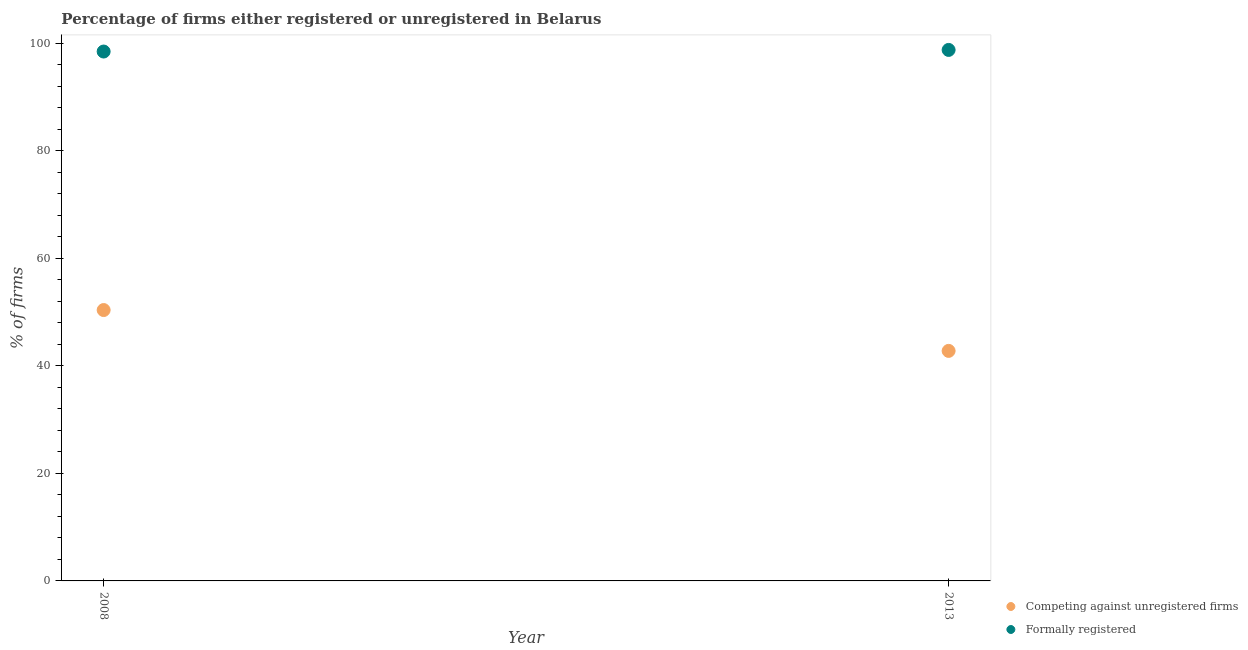Is the number of dotlines equal to the number of legend labels?
Offer a very short reply. Yes. What is the percentage of registered firms in 2008?
Your answer should be compact. 50.4. Across all years, what is the maximum percentage of formally registered firms?
Your answer should be compact. 98.8. Across all years, what is the minimum percentage of registered firms?
Keep it short and to the point. 42.8. In which year was the percentage of formally registered firms minimum?
Make the answer very short. 2008. What is the total percentage of registered firms in the graph?
Your answer should be compact. 93.2. What is the difference between the percentage of formally registered firms in 2008 and that in 2013?
Make the answer very short. -0.3. What is the difference between the percentage of registered firms in 2013 and the percentage of formally registered firms in 2008?
Ensure brevity in your answer.  -55.7. What is the average percentage of formally registered firms per year?
Offer a very short reply. 98.65. In the year 2008, what is the difference between the percentage of formally registered firms and percentage of registered firms?
Keep it short and to the point. 48.1. What is the ratio of the percentage of formally registered firms in 2008 to that in 2013?
Offer a terse response. 1. In how many years, is the percentage of formally registered firms greater than the average percentage of formally registered firms taken over all years?
Provide a short and direct response. 1. Does the percentage of formally registered firms monotonically increase over the years?
Offer a very short reply. Yes. Is the percentage of formally registered firms strictly greater than the percentage of registered firms over the years?
Provide a succinct answer. Yes. What is the difference between two consecutive major ticks on the Y-axis?
Ensure brevity in your answer.  20. How many legend labels are there?
Provide a succinct answer. 2. What is the title of the graph?
Ensure brevity in your answer.  Percentage of firms either registered or unregistered in Belarus. What is the label or title of the Y-axis?
Make the answer very short. % of firms. What is the % of firms in Competing against unregistered firms in 2008?
Offer a very short reply. 50.4. What is the % of firms in Formally registered in 2008?
Your answer should be very brief. 98.5. What is the % of firms in Competing against unregistered firms in 2013?
Your answer should be very brief. 42.8. What is the % of firms of Formally registered in 2013?
Keep it short and to the point. 98.8. Across all years, what is the maximum % of firms in Competing against unregistered firms?
Make the answer very short. 50.4. Across all years, what is the maximum % of firms in Formally registered?
Provide a succinct answer. 98.8. Across all years, what is the minimum % of firms in Competing against unregistered firms?
Offer a very short reply. 42.8. Across all years, what is the minimum % of firms of Formally registered?
Offer a very short reply. 98.5. What is the total % of firms of Competing against unregistered firms in the graph?
Keep it short and to the point. 93.2. What is the total % of firms in Formally registered in the graph?
Make the answer very short. 197.3. What is the difference between the % of firms of Formally registered in 2008 and that in 2013?
Ensure brevity in your answer.  -0.3. What is the difference between the % of firms of Competing against unregistered firms in 2008 and the % of firms of Formally registered in 2013?
Provide a succinct answer. -48.4. What is the average % of firms in Competing against unregistered firms per year?
Your answer should be very brief. 46.6. What is the average % of firms in Formally registered per year?
Your response must be concise. 98.65. In the year 2008, what is the difference between the % of firms of Competing against unregistered firms and % of firms of Formally registered?
Your answer should be compact. -48.1. In the year 2013, what is the difference between the % of firms of Competing against unregistered firms and % of firms of Formally registered?
Offer a very short reply. -56. What is the ratio of the % of firms in Competing against unregistered firms in 2008 to that in 2013?
Your answer should be very brief. 1.18. What is the difference between the highest and the second highest % of firms in Formally registered?
Your answer should be very brief. 0.3. 